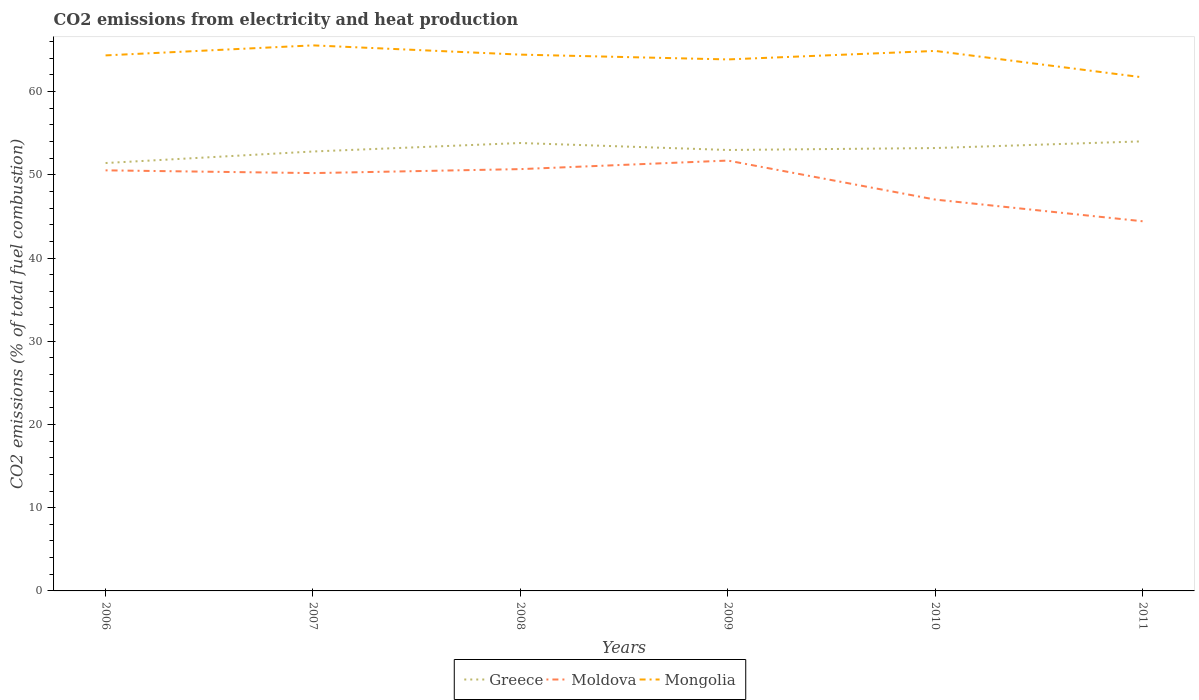How many different coloured lines are there?
Keep it short and to the point. 3. Is the number of lines equal to the number of legend labels?
Your answer should be very brief. Yes. Across all years, what is the maximum amount of CO2 emitted in Moldova?
Provide a succinct answer. 44.42. In which year was the amount of CO2 emitted in Mongolia maximum?
Your answer should be compact. 2011. What is the total amount of CO2 emitted in Greece in the graph?
Keep it short and to the point. 0.61. What is the difference between the highest and the second highest amount of CO2 emitted in Greece?
Offer a very short reply. 2.61. Is the amount of CO2 emitted in Moldova strictly greater than the amount of CO2 emitted in Mongolia over the years?
Offer a very short reply. Yes. How many lines are there?
Provide a succinct answer. 3. What is the difference between two consecutive major ticks on the Y-axis?
Your response must be concise. 10. Does the graph contain grids?
Keep it short and to the point. No. What is the title of the graph?
Offer a terse response. CO2 emissions from electricity and heat production. What is the label or title of the Y-axis?
Your answer should be compact. CO2 emissions (% of total fuel combustion). What is the CO2 emissions (% of total fuel combustion) in Greece in 2006?
Your answer should be very brief. 51.41. What is the CO2 emissions (% of total fuel combustion) in Moldova in 2006?
Your answer should be compact. 50.53. What is the CO2 emissions (% of total fuel combustion) of Mongolia in 2006?
Provide a succinct answer. 64.35. What is the CO2 emissions (% of total fuel combustion) of Greece in 2007?
Make the answer very short. 52.8. What is the CO2 emissions (% of total fuel combustion) in Moldova in 2007?
Ensure brevity in your answer.  50.2. What is the CO2 emissions (% of total fuel combustion) in Mongolia in 2007?
Make the answer very short. 65.55. What is the CO2 emissions (% of total fuel combustion) in Greece in 2008?
Offer a terse response. 53.82. What is the CO2 emissions (% of total fuel combustion) in Moldova in 2008?
Ensure brevity in your answer.  50.68. What is the CO2 emissions (% of total fuel combustion) of Mongolia in 2008?
Provide a succinct answer. 64.44. What is the CO2 emissions (% of total fuel combustion) in Greece in 2009?
Offer a terse response. 52.98. What is the CO2 emissions (% of total fuel combustion) of Moldova in 2009?
Give a very brief answer. 51.71. What is the CO2 emissions (% of total fuel combustion) in Mongolia in 2009?
Ensure brevity in your answer.  63.86. What is the CO2 emissions (% of total fuel combustion) in Greece in 2010?
Provide a succinct answer. 53.21. What is the CO2 emissions (% of total fuel combustion) in Moldova in 2010?
Give a very brief answer. 47.02. What is the CO2 emissions (% of total fuel combustion) of Mongolia in 2010?
Ensure brevity in your answer.  64.88. What is the CO2 emissions (% of total fuel combustion) of Greece in 2011?
Make the answer very short. 54.02. What is the CO2 emissions (% of total fuel combustion) of Moldova in 2011?
Your answer should be compact. 44.42. What is the CO2 emissions (% of total fuel combustion) of Mongolia in 2011?
Your answer should be compact. 61.71. Across all years, what is the maximum CO2 emissions (% of total fuel combustion) of Greece?
Your answer should be compact. 54.02. Across all years, what is the maximum CO2 emissions (% of total fuel combustion) in Moldova?
Offer a very short reply. 51.71. Across all years, what is the maximum CO2 emissions (% of total fuel combustion) in Mongolia?
Offer a very short reply. 65.55. Across all years, what is the minimum CO2 emissions (% of total fuel combustion) of Greece?
Make the answer very short. 51.41. Across all years, what is the minimum CO2 emissions (% of total fuel combustion) of Moldova?
Give a very brief answer. 44.42. Across all years, what is the minimum CO2 emissions (% of total fuel combustion) in Mongolia?
Give a very brief answer. 61.71. What is the total CO2 emissions (% of total fuel combustion) of Greece in the graph?
Your answer should be very brief. 318.25. What is the total CO2 emissions (% of total fuel combustion) of Moldova in the graph?
Give a very brief answer. 294.57. What is the total CO2 emissions (% of total fuel combustion) in Mongolia in the graph?
Make the answer very short. 384.8. What is the difference between the CO2 emissions (% of total fuel combustion) in Greece in 2006 and that in 2007?
Provide a short and direct response. -1.39. What is the difference between the CO2 emissions (% of total fuel combustion) in Moldova in 2006 and that in 2007?
Give a very brief answer. 0.33. What is the difference between the CO2 emissions (% of total fuel combustion) of Mongolia in 2006 and that in 2007?
Your answer should be very brief. -1.2. What is the difference between the CO2 emissions (% of total fuel combustion) in Greece in 2006 and that in 2008?
Keep it short and to the point. -2.41. What is the difference between the CO2 emissions (% of total fuel combustion) in Moldova in 2006 and that in 2008?
Give a very brief answer. -0.15. What is the difference between the CO2 emissions (% of total fuel combustion) in Mongolia in 2006 and that in 2008?
Your answer should be very brief. -0.09. What is the difference between the CO2 emissions (% of total fuel combustion) in Greece in 2006 and that in 2009?
Your response must be concise. -1.57. What is the difference between the CO2 emissions (% of total fuel combustion) in Moldova in 2006 and that in 2009?
Offer a very short reply. -1.18. What is the difference between the CO2 emissions (% of total fuel combustion) in Mongolia in 2006 and that in 2009?
Make the answer very short. 0.48. What is the difference between the CO2 emissions (% of total fuel combustion) of Greece in 2006 and that in 2010?
Offer a very short reply. -1.8. What is the difference between the CO2 emissions (% of total fuel combustion) in Moldova in 2006 and that in 2010?
Your answer should be compact. 3.51. What is the difference between the CO2 emissions (% of total fuel combustion) in Mongolia in 2006 and that in 2010?
Offer a very short reply. -0.54. What is the difference between the CO2 emissions (% of total fuel combustion) of Greece in 2006 and that in 2011?
Provide a short and direct response. -2.61. What is the difference between the CO2 emissions (% of total fuel combustion) of Moldova in 2006 and that in 2011?
Provide a succinct answer. 6.12. What is the difference between the CO2 emissions (% of total fuel combustion) of Mongolia in 2006 and that in 2011?
Keep it short and to the point. 2.64. What is the difference between the CO2 emissions (% of total fuel combustion) of Greece in 2007 and that in 2008?
Keep it short and to the point. -1.02. What is the difference between the CO2 emissions (% of total fuel combustion) in Moldova in 2007 and that in 2008?
Your answer should be very brief. -0.48. What is the difference between the CO2 emissions (% of total fuel combustion) of Greece in 2007 and that in 2009?
Offer a terse response. -0.18. What is the difference between the CO2 emissions (% of total fuel combustion) of Moldova in 2007 and that in 2009?
Keep it short and to the point. -1.51. What is the difference between the CO2 emissions (% of total fuel combustion) in Mongolia in 2007 and that in 2009?
Provide a short and direct response. 1.69. What is the difference between the CO2 emissions (% of total fuel combustion) in Greece in 2007 and that in 2010?
Ensure brevity in your answer.  -0.41. What is the difference between the CO2 emissions (% of total fuel combustion) in Moldova in 2007 and that in 2010?
Your answer should be very brief. 3.18. What is the difference between the CO2 emissions (% of total fuel combustion) of Mongolia in 2007 and that in 2010?
Keep it short and to the point. 0.67. What is the difference between the CO2 emissions (% of total fuel combustion) of Greece in 2007 and that in 2011?
Give a very brief answer. -1.22. What is the difference between the CO2 emissions (% of total fuel combustion) in Moldova in 2007 and that in 2011?
Offer a terse response. 5.79. What is the difference between the CO2 emissions (% of total fuel combustion) of Mongolia in 2007 and that in 2011?
Offer a terse response. 3.84. What is the difference between the CO2 emissions (% of total fuel combustion) of Greece in 2008 and that in 2009?
Keep it short and to the point. 0.84. What is the difference between the CO2 emissions (% of total fuel combustion) in Moldova in 2008 and that in 2009?
Your answer should be compact. -1.03. What is the difference between the CO2 emissions (% of total fuel combustion) of Mongolia in 2008 and that in 2009?
Provide a succinct answer. 0.58. What is the difference between the CO2 emissions (% of total fuel combustion) of Greece in 2008 and that in 2010?
Your response must be concise. 0.61. What is the difference between the CO2 emissions (% of total fuel combustion) in Moldova in 2008 and that in 2010?
Make the answer very short. 3.66. What is the difference between the CO2 emissions (% of total fuel combustion) in Mongolia in 2008 and that in 2010?
Give a very brief answer. -0.44. What is the difference between the CO2 emissions (% of total fuel combustion) of Greece in 2008 and that in 2011?
Make the answer very short. -0.2. What is the difference between the CO2 emissions (% of total fuel combustion) of Moldova in 2008 and that in 2011?
Your answer should be very brief. 6.27. What is the difference between the CO2 emissions (% of total fuel combustion) of Mongolia in 2008 and that in 2011?
Offer a very short reply. 2.73. What is the difference between the CO2 emissions (% of total fuel combustion) of Greece in 2009 and that in 2010?
Give a very brief answer. -0.23. What is the difference between the CO2 emissions (% of total fuel combustion) in Moldova in 2009 and that in 2010?
Your answer should be very brief. 4.69. What is the difference between the CO2 emissions (% of total fuel combustion) in Mongolia in 2009 and that in 2010?
Give a very brief answer. -1.02. What is the difference between the CO2 emissions (% of total fuel combustion) in Greece in 2009 and that in 2011?
Offer a very short reply. -1.04. What is the difference between the CO2 emissions (% of total fuel combustion) in Moldova in 2009 and that in 2011?
Your answer should be compact. 7.29. What is the difference between the CO2 emissions (% of total fuel combustion) in Mongolia in 2009 and that in 2011?
Your answer should be very brief. 2.15. What is the difference between the CO2 emissions (% of total fuel combustion) in Greece in 2010 and that in 2011?
Ensure brevity in your answer.  -0.81. What is the difference between the CO2 emissions (% of total fuel combustion) in Moldova in 2010 and that in 2011?
Keep it short and to the point. 2.61. What is the difference between the CO2 emissions (% of total fuel combustion) in Mongolia in 2010 and that in 2011?
Offer a terse response. 3.17. What is the difference between the CO2 emissions (% of total fuel combustion) in Greece in 2006 and the CO2 emissions (% of total fuel combustion) in Moldova in 2007?
Provide a succinct answer. 1.21. What is the difference between the CO2 emissions (% of total fuel combustion) of Greece in 2006 and the CO2 emissions (% of total fuel combustion) of Mongolia in 2007?
Your response must be concise. -14.14. What is the difference between the CO2 emissions (% of total fuel combustion) in Moldova in 2006 and the CO2 emissions (% of total fuel combustion) in Mongolia in 2007?
Your answer should be very brief. -15.02. What is the difference between the CO2 emissions (% of total fuel combustion) in Greece in 2006 and the CO2 emissions (% of total fuel combustion) in Moldova in 2008?
Provide a short and direct response. 0.73. What is the difference between the CO2 emissions (% of total fuel combustion) of Greece in 2006 and the CO2 emissions (% of total fuel combustion) of Mongolia in 2008?
Give a very brief answer. -13.03. What is the difference between the CO2 emissions (% of total fuel combustion) in Moldova in 2006 and the CO2 emissions (% of total fuel combustion) in Mongolia in 2008?
Provide a short and direct response. -13.91. What is the difference between the CO2 emissions (% of total fuel combustion) of Greece in 2006 and the CO2 emissions (% of total fuel combustion) of Moldova in 2009?
Your answer should be very brief. -0.3. What is the difference between the CO2 emissions (% of total fuel combustion) of Greece in 2006 and the CO2 emissions (% of total fuel combustion) of Mongolia in 2009?
Make the answer very short. -12.45. What is the difference between the CO2 emissions (% of total fuel combustion) of Moldova in 2006 and the CO2 emissions (% of total fuel combustion) of Mongolia in 2009?
Offer a terse response. -13.33. What is the difference between the CO2 emissions (% of total fuel combustion) in Greece in 2006 and the CO2 emissions (% of total fuel combustion) in Moldova in 2010?
Give a very brief answer. 4.39. What is the difference between the CO2 emissions (% of total fuel combustion) of Greece in 2006 and the CO2 emissions (% of total fuel combustion) of Mongolia in 2010?
Provide a succinct answer. -13.47. What is the difference between the CO2 emissions (% of total fuel combustion) of Moldova in 2006 and the CO2 emissions (% of total fuel combustion) of Mongolia in 2010?
Keep it short and to the point. -14.35. What is the difference between the CO2 emissions (% of total fuel combustion) in Greece in 2006 and the CO2 emissions (% of total fuel combustion) in Moldova in 2011?
Provide a succinct answer. 7. What is the difference between the CO2 emissions (% of total fuel combustion) in Greece in 2006 and the CO2 emissions (% of total fuel combustion) in Mongolia in 2011?
Ensure brevity in your answer.  -10.3. What is the difference between the CO2 emissions (% of total fuel combustion) in Moldova in 2006 and the CO2 emissions (% of total fuel combustion) in Mongolia in 2011?
Offer a terse response. -11.18. What is the difference between the CO2 emissions (% of total fuel combustion) in Greece in 2007 and the CO2 emissions (% of total fuel combustion) in Moldova in 2008?
Offer a terse response. 2.12. What is the difference between the CO2 emissions (% of total fuel combustion) in Greece in 2007 and the CO2 emissions (% of total fuel combustion) in Mongolia in 2008?
Your response must be concise. -11.64. What is the difference between the CO2 emissions (% of total fuel combustion) of Moldova in 2007 and the CO2 emissions (% of total fuel combustion) of Mongolia in 2008?
Offer a very short reply. -14.24. What is the difference between the CO2 emissions (% of total fuel combustion) of Greece in 2007 and the CO2 emissions (% of total fuel combustion) of Moldova in 2009?
Provide a short and direct response. 1.09. What is the difference between the CO2 emissions (% of total fuel combustion) of Greece in 2007 and the CO2 emissions (% of total fuel combustion) of Mongolia in 2009?
Give a very brief answer. -11.06. What is the difference between the CO2 emissions (% of total fuel combustion) of Moldova in 2007 and the CO2 emissions (% of total fuel combustion) of Mongolia in 2009?
Offer a very short reply. -13.66. What is the difference between the CO2 emissions (% of total fuel combustion) of Greece in 2007 and the CO2 emissions (% of total fuel combustion) of Moldova in 2010?
Keep it short and to the point. 5.78. What is the difference between the CO2 emissions (% of total fuel combustion) in Greece in 2007 and the CO2 emissions (% of total fuel combustion) in Mongolia in 2010?
Your response must be concise. -12.08. What is the difference between the CO2 emissions (% of total fuel combustion) in Moldova in 2007 and the CO2 emissions (% of total fuel combustion) in Mongolia in 2010?
Your answer should be very brief. -14.68. What is the difference between the CO2 emissions (% of total fuel combustion) in Greece in 2007 and the CO2 emissions (% of total fuel combustion) in Moldova in 2011?
Make the answer very short. 8.38. What is the difference between the CO2 emissions (% of total fuel combustion) in Greece in 2007 and the CO2 emissions (% of total fuel combustion) in Mongolia in 2011?
Offer a very short reply. -8.91. What is the difference between the CO2 emissions (% of total fuel combustion) of Moldova in 2007 and the CO2 emissions (% of total fuel combustion) of Mongolia in 2011?
Keep it short and to the point. -11.51. What is the difference between the CO2 emissions (% of total fuel combustion) in Greece in 2008 and the CO2 emissions (% of total fuel combustion) in Moldova in 2009?
Offer a terse response. 2.11. What is the difference between the CO2 emissions (% of total fuel combustion) of Greece in 2008 and the CO2 emissions (% of total fuel combustion) of Mongolia in 2009?
Your answer should be very brief. -10.04. What is the difference between the CO2 emissions (% of total fuel combustion) of Moldova in 2008 and the CO2 emissions (% of total fuel combustion) of Mongolia in 2009?
Offer a terse response. -13.18. What is the difference between the CO2 emissions (% of total fuel combustion) in Greece in 2008 and the CO2 emissions (% of total fuel combustion) in Moldova in 2010?
Offer a terse response. 6.8. What is the difference between the CO2 emissions (% of total fuel combustion) in Greece in 2008 and the CO2 emissions (% of total fuel combustion) in Mongolia in 2010?
Provide a short and direct response. -11.07. What is the difference between the CO2 emissions (% of total fuel combustion) of Moldova in 2008 and the CO2 emissions (% of total fuel combustion) of Mongolia in 2010?
Keep it short and to the point. -14.2. What is the difference between the CO2 emissions (% of total fuel combustion) in Greece in 2008 and the CO2 emissions (% of total fuel combustion) in Moldova in 2011?
Provide a short and direct response. 9.4. What is the difference between the CO2 emissions (% of total fuel combustion) in Greece in 2008 and the CO2 emissions (% of total fuel combustion) in Mongolia in 2011?
Your response must be concise. -7.89. What is the difference between the CO2 emissions (% of total fuel combustion) in Moldova in 2008 and the CO2 emissions (% of total fuel combustion) in Mongolia in 2011?
Your response must be concise. -11.03. What is the difference between the CO2 emissions (% of total fuel combustion) of Greece in 2009 and the CO2 emissions (% of total fuel combustion) of Moldova in 2010?
Give a very brief answer. 5.96. What is the difference between the CO2 emissions (% of total fuel combustion) in Greece in 2009 and the CO2 emissions (% of total fuel combustion) in Mongolia in 2010?
Make the answer very short. -11.9. What is the difference between the CO2 emissions (% of total fuel combustion) of Moldova in 2009 and the CO2 emissions (% of total fuel combustion) of Mongolia in 2010?
Provide a short and direct response. -13.17. What is the difference between the CO2 emissions (% of total fuel combustion) of Greece in 2009 and the CO2 emissions (% of total fuel combustion) of Moldova in 2011?
Provide a short and direct response. 8.57. What is the difference between the CO2 emissions (% of total fuel combustion) of Greece in 2009 and the CO2 emissions (% of total fuel combustion) of Mongolia in 2011?
Your response must be concise. -8.73. What is the difference between the CO2 emissions (% of total fuel combustion) in Moldova in 2009 and the CO2 emissions (% of total fuel combustion) in Mongolia in 2011?
Make the answer very short. -10. What is the difference between the CO2 emissions (% of total fuel combustion) of Greece in 2010 and the CO2 emissions (% of total fuel combustion) of Moldova in 2011?
Your response must be concise. 8.8. What is the difference between the CO2 emissions (% of total fuel combustion) of Greece in 2010 and the CO2 emissions (% of total fuel combustion) of Mongolia in 2011?
Ensure brevity in your answer.  -8.5. What is the difference between the CO2 emissions (% of total fuel combustion) of Moldova in 2010 and the CO2 emissions (% of total fuel combustion) of Mongolia in 2011?
Your response must be concise. -14.69. What is the average CO2 emissions (% of total fuel combustion) of Greece per year?
Provide a short and direct response. 53.04. What is the average CO2 emissions (% of total fuel combustion) in Moldova per year?
Offer a terse response. 49.09. What is the average CO2 emissions (% of total fuel combustion) of Mongolia per year?
Your response must be concise. 64.13. In the year 2006, what is the difference between the CO2 emissions (% of total fuel combustion) in Greece and CO2 emissions (% of total fuel combustion) in Moldova?
Your response must be concise. 0.88. In the year 2006, what is the difference between the CO2 emissions (% of total fuel combustion) of Greece and CO2 emissions (% of total fuel combustion) of Mongolia?
Give a very brief answer. -12.93. In the year 2006, what is the difference between the CO2 emissions (% of total fuel combustion) of Moldova and CO2 emissions (% of total fuel combustion) of Mongolia?
Keep it short and to the point. -13.81. In the year 2007, what is the difference between the CO2 emissions (% of total fuel combustion) of Greece and CO2 emissions (% of total fuel combustion) of Moldova?
Your response must be concise. 2.6. In the year 2007, what is the difference between the CO2 emissions (% of total fuel combustion) of Greece and CO2 emissions (% of total fuel combustion) of Mongolia?
Offer a very short reply. -12.75. In the year 2007, what is the difference between the CO2 emissions (% of total fuel combustion) in Moldova and CO2 emissions (% of total fuel combustion) in Mongolia?
Provide a short and direct response. -15.35. In the year 2008, what is the difference between the CO2 emissions (% of total fuel combustion) of Greece and CO2 emissions (% of total fuel combustion) of Moldova?
Your response must be concise. 3.14. In the year 2008, what is the difference between the CO2 emissions (% of total fuel combustion) of Greece and CO2 emissions (% of total fuel combustion) of Mongolia?
Your answer should be compact. -10.62. In the year 2008, what is the difference between the CO2 emissions (% of total fuel combustion) of Moldova and CO2 emissions (% of total fuel combustion) of Mongolia?
Make the answer very short. -13.76. In the year 2009, what is the difference between the CO2 emissions (% of total fuel combustion) in Greece and CO2 emissions (% of total fuel combustion) in Moldova?
Provide a short and direct response. 1.27. In the year 2009, what is the difference between the CO2 emissions (% of total fuel combustion) in Greece and CO2 emissions (% of total fuel combustion) in Mongolia?
Make the answer very short. -10.88. In the year 2009, what is the difference between the CO2 emissions (% of total fuel combustion) of Moldova and CO2 emissions (% of total fuel combustion) of Mongolia?
Ensure brevity in your answer.  -12.15. In the year 2010, what is the difference between the CO2 emissions (% of total fuel combustion) in Greece and CO2 emissions (% of total fuel combustion) in Moldova?
Provide a short and direct response. 6.19. In the year 2010, what is the difference between the CO2 emissions (% of total fuel combustion) of Greece and CO2 emissions (% of total fuel combustion) of Mongolia?
Offer a very short reply. -11.67. In the year 2010, what is the difference between the CO2 emissions (% of total fuel combustion) of Moldova and CO2 emissions (% of total fuel combustion) of Mongolia?
Your answer should be very brief. -17.86. In the year 2011, what is the difference between the CO2 emissions (% of total fuel combustion) in Greece and CO2 emissions (% of total fuel combustion) in Moldova?
Provide a succinct answer. 9.6. In the year 2011, what is the difference between the CO2 emissions (% of total fuel combustion) in Greece and CO2 emissions (% of total fuel combustion) in Mongolia?
Offer a terse response. -7.69. In the year 2011, what is the difference between the CO2 emissions (% of total fuel combustion) of Moldova and CO2 emissions (% of total fuel combustion) of Mongolia?
Provide a short and direct response. -17.29. What is the ratio of the CO2 emissions (% of total fuel combustion) of Greece in 2006 to that in 2007?
Ensure brevity in your answer.  0.97. What is the ratio of the CO2 emissions (% of total fuel combustion) in Moldova in 2006 to that in 2007?
Give a very brief answer. 1.01. What is the ratio of the CO2 emissions (% of total fuel combustion) of Mongolia in 2006 to that in 2007?
Make the answer very short. 0.98. What is the ratio of the CO2 emissions (% of total fuel combustion) of Greece in 2006 to that in 2008?
Keep it short and to the point. 0.96. What is the ratio of the CO2 emissions (% of total fuel combustion) of Mongolia in 2006 to that in 2008?
Keep it short and to the point. 1. What is the ratio of the CO2 emissions (% of total fuel combustion) of Greece in 2006 to that in 2009?
Offer a terse response. 0.97. What is the ratio of the CO2 emissions (% of total fuel combustion) of Moldova in 2006 to that in 2009?
Give a very brief answer. 0.98. What is the ratio of the CO2 emissions (% of total fuel combustion) of Mongolia in 2006 to that in 2009?
Make the answer very short. 1.01. What is the ratio of the CO2 emissions (% of total fuel combustion) in Greece in 2006 to that in 2010?
Offer a terse response. 0.97. What is the ratio of the CO2 emissions (% of total fuel combustion) in Moldova in 2006 to that in 2010?
Provide a succinct answer. 1.07. What is the ratio of the CO2 emissions (% of total fuel combustion) of Greece in 2006 to that in 2011?
Give a very brief answer. 0.95. What is the ratio of the CO2 emissions (% of total fuel combustion) in Moldova in 2006 to that in 2011?
Give a very brief answer. 1.14. What is the ratio of the CO2 emissions (% of total fuel combustion) in Mongolia in 2006 to that in 2011?
Your answer should be compact. 1.04. What is the ratio of the CO2 emissions (% of total fuel combustion) of Greece in 2007 to that in 2008?
Offer a terse response. 0.98. What is the ratio of the CO2 emissions (% of total fuel combustion) in Mongolia in 2007 to that in 2008?
Offer a terse response. 1.02. What is the ratio of the CO2 emissions (% of total fuel combustion) in Moldova in 2007 to that in 2009?
Offer a very short reply. 0.97. What is the ratio of the CO2 emissions (% of total fuel combustion) of Mongolia in 2007 to that in 2009?
Your answer should be compact. 1.03. What is the ratio of the CO2 emissions (% of total fuel combustion) of Moldova in 2007 to that in 2010?
Your answer should be very brief. 1.07. What is the ratio of the CO2 emissions (% of total fuel combustion) in Mongolia in 2007 to that in 2010?
Ensure brevity in your answer.  1.01. What is the ratio of the CO2 emissions (% of total fuel combustion) in Greece in 2007 to that in 2011?
Provide a succinct answer. 0.98. What is the ratio of the CO2 emissions (% of total fuel combustion) of Moldova in 2007 to that in 2011?
Your response must be concise. 1.13. What is the ratio of the CO2 emissions (% of total fuel combustion) of Mongolia in 2007 to that in 2011?
Provide a short and direct response. 1.06. What is the ratio of the CO2 emissions (% of total fuel combustion) of Greece in 2008 to that in 2009?
Keep it short and to the point. 1.02. What is the ratio of the CO2 emissions (% of total fuel combustion) of Moldova in 2008 to that in 2009?
Ensure brevity in your answer.  0.98. What is the ratio of the CO2 emissions (% of total fuel combustion) in Mongolia in 2008 to that in 2009?
Keep it short and to the point. 1.01. What is the ratio of the CO2 emissions (% of total fuel combustion) of Greece in 2008 to that in 2010?
Give a very brief answer. 1.01. What is the ratio of the CO2 emissions (% of total fuel combustion) in Moldova in 2008 to that in 2010?
Make the answer very short. 1.08. What is the ratio of the CO2 emissions (% of total fuel combustion) of Moldova in 2008 to that in 2011?
Offer a terse response. 1.14. What is the ratio of the CO2 emissions (% of total fuel combustion) in Mongolia in 2008 to that in 2011?
Your response must be concise. 1.04. What is the ratio of the CO2 emissions (% of total fuel combustion) in Greece in 2009 to that in 2010?
Ensure brevity in your answer.  1. What is the ratio of the CO2 emissions (% of total fuel combustion) of Moldova in 2009 to that in 2010?
Offer a very short reply. 1.1. What is the ratio of the CO2 emissions (% of total fuel combustion) of Mongolia in 2009 to that in 2010?
Ensure brevity in your answer.  0.98. What is the ratio of the CO2 emissions (% of total fuel combustion) of Greece in 2009 to that in 2011?
Ensure brevity in your answer.  0.98. What is the ratio of the CO2 emissions (% of total fuel combustion) in Moldova in 2009 to that in 2011?
Ensure brevity in your answer.  1.16. What is the ratio of the CO2 emissions (% of total fuel combustion) in Mongolia in 2009 to that in 2011?
Your response must be concise. 1.03. What is the ratio of the CO2 emissions (% of total fuel combustion) of Greece in 2010 to that in 2011?
Your response must be concise. 0.99. What is the ratio of the CO2 emissions (% of total fuel combustion) of Moldova in 2010 to that in 2011?
Give a very brief answer. 1.06. What is the ratio of the CO2 emissions (% of total fuel combustion) in Mongolia in 2010 to that in 2011?
Offer a very short reply. 1.05. What is the difference between the highest and the second highest CO2 emissions (% of total fuel combustion) in Greece?
Ensure brevity in your answer.  0.2. What is the difference between the highest and the second highest CO2 emissions (% of total fuel combustion) in Moldova?
Give a very brief answer. 1.03. What is the difference between the highest and the second highest CO2 emissions (% of total fuel combustion) of Mongolia?
Provide a succinct answer. 0.67. What is the difference between the highest and the lowest CO2 emissions (% of total fuel combustion) of Greece?
Make the answer very short. 2.61. What is the difference between the highest and the lowest CO2 emissions (% of total fuel combustion) in Moldova?
Your response must be concise. 7.29. What is the difference between the highest and the lowest CO2 emissions (% of total fuel combustion) of Mongolia?
Give a very brief answer. 3.84. 